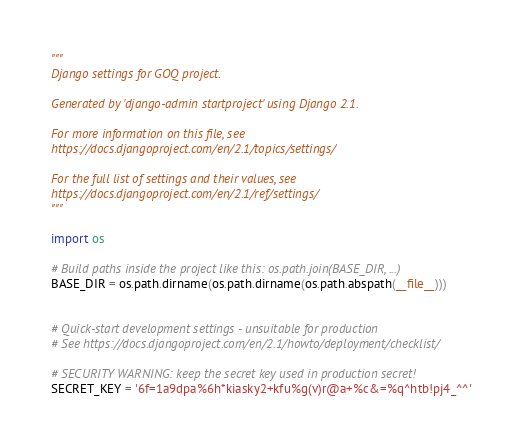Convert code to text. <code><loc_0><loc_0><loc_500><loc_500><_Python_>"""
Django settings for GOQ project.

Generated by 'django-admin startproject' using Django 2.1.

For more information on this file, see
https://docs.djangoproject.com/en/2.1/topics/settings/

For the full list of settings and their values, see
https://docs.djangoproject.com/en/2.1/ref/settings/
"""

import os

# Build paths inside the project like this: os.path.join(BASE_DIR, ...)
BASE_DIR = os.path.dirname(os.path.dirname(os.path.abspath(__file__)))


# Quick-start development settings - unsuitable for production
# See https://docs.djangoproject.com/en/2.1/howto/deployment/checklist/

# SECURITY WARNING: keep the secret key used in production secret!
SECRET_KEY = '6f=1a9dpa%6h*kiasky2+kfu%g(v)r@a+%c&=%q^htb!pj4_^^'
</code> 